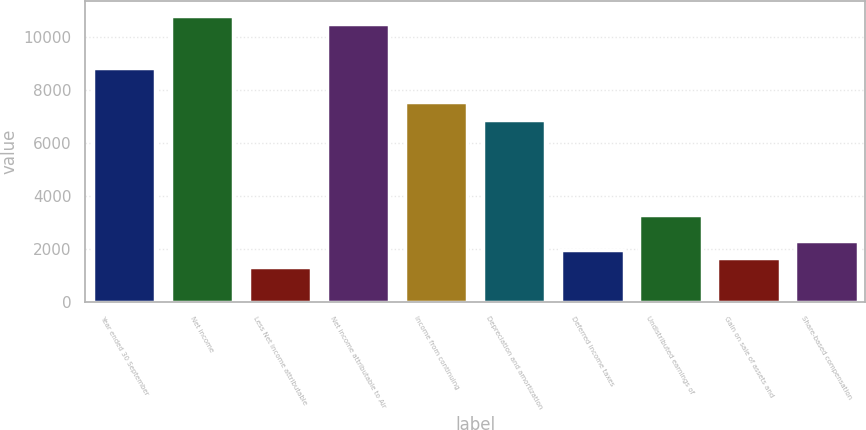Convert chart to OTSL. <chart><loc_0><loc_0><loc_500><loc_500><bar_chart><fcel>Year ended 30 September<fcel>Net income<fcel>Less Net income attributable<fcel>Net income attributable to Air<fcel>Income from continuing<fcel>Depreciation and amortization<fcel>Deferred income taxes<fcel>Undistributed earnings of<fcel>Gain on sale of assets and<fcel>Share-based compensation<nl><fcel>8832.94<fcel>10795.1<fcel>1311.48<fcel>10468<fcel>7524.86<fcel>6870.82<fcel>1965.52<fcel>3273.6<fcel>1638.5<fcel>2292.54<nl></chart> 